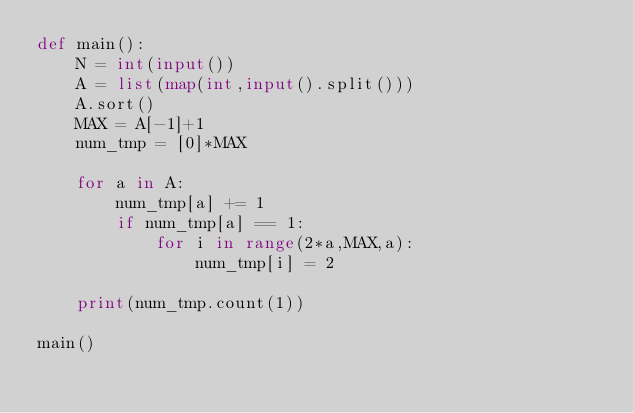Convert code to text. <code><loc_0><loc_0><loc_500><loc_500><_Python_>def main():
    N = int(input())
    A = list(map(int,input().split()))
    A.sort()
    MAX = A[-1]+1
    num_tmp = [0]*MAX

    for a in A:
        num_tmp[a] += 1
        if num_tmp[a] == 1:
            for i in range(2*a,MAX,a):
                num_tmp[i] = 2

    print(num_tmp.count(1))
    
main()</code> 